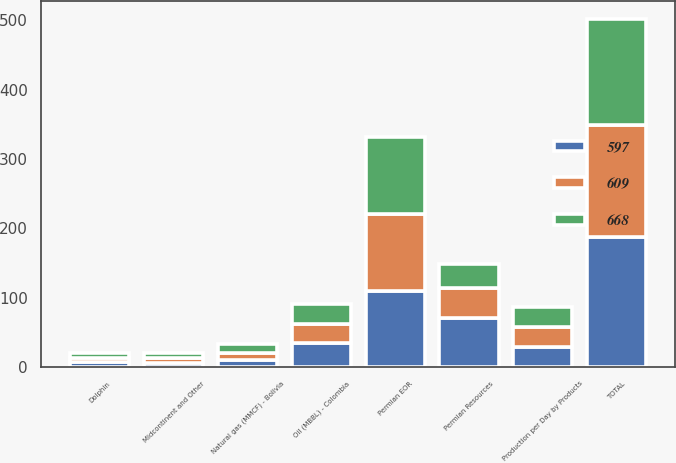Convert chart. <chart><loc_0><loc_0><loc_500><loc_500><stacked_bar_chart><ecel><fcel>Production per Day by Products<fcel>Permian Resources<fcel>Permian EOR<fcel>Midcontinent and Other<fcel>TOTAL<fcel>Oil (MBBL) - Colombia<fcel>Natural gas (MMCF) - Bolivia<fcel>Dolphin<nl><fcel>597<fcel>29<fcel>71<fcel>110<fcel>6<fcel>187<fcel>35<fcel>10<fcel>7<nl><fcel>609<fcel>29<fcel>43<fcel>111<fcel>8<fcel>162<fcel>27<fcel>11<fcel>7<nl><fcel>668<fcel>29<fcel>35<fcel>111<fcel>7<fcel>153<fcel>29<fcel>12<fcel>6<nl></chart> 